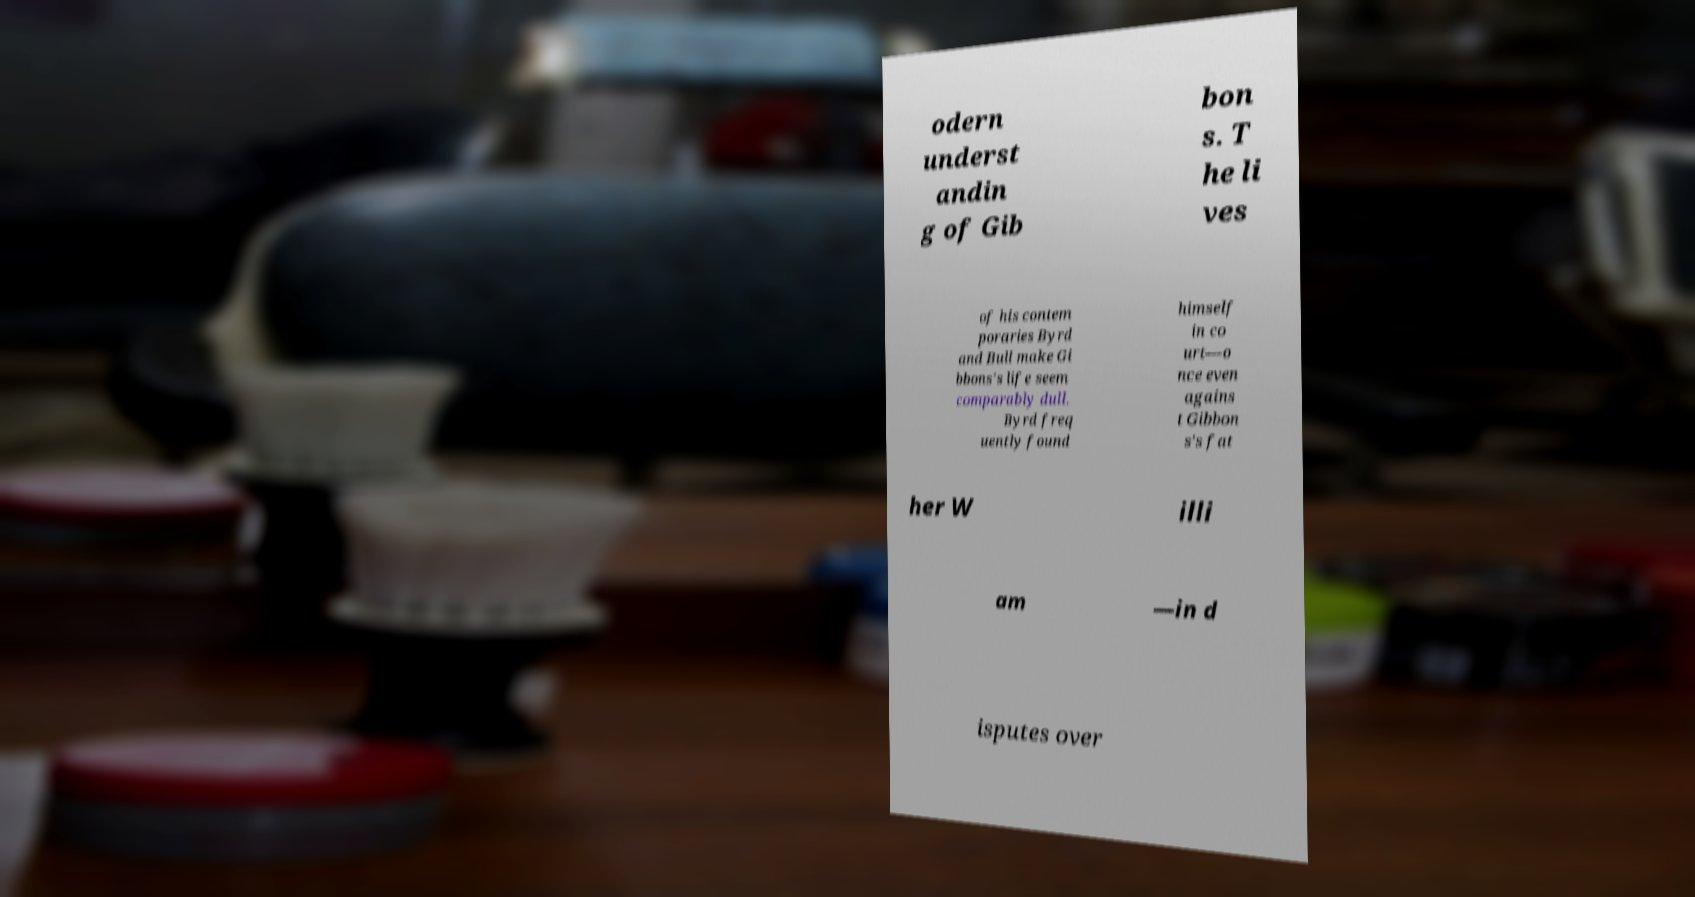Please read and relay the text visible in this image. What does it say? odern underst andin g of Gib bon s. T he li ves of his contem poraries Byrd and Bull make Gi bbons's life seem comparably dull. Byrd freq uently found himself in co urt—o nce even agains t Gibbon s's fat her W illi am —in d isputes over 